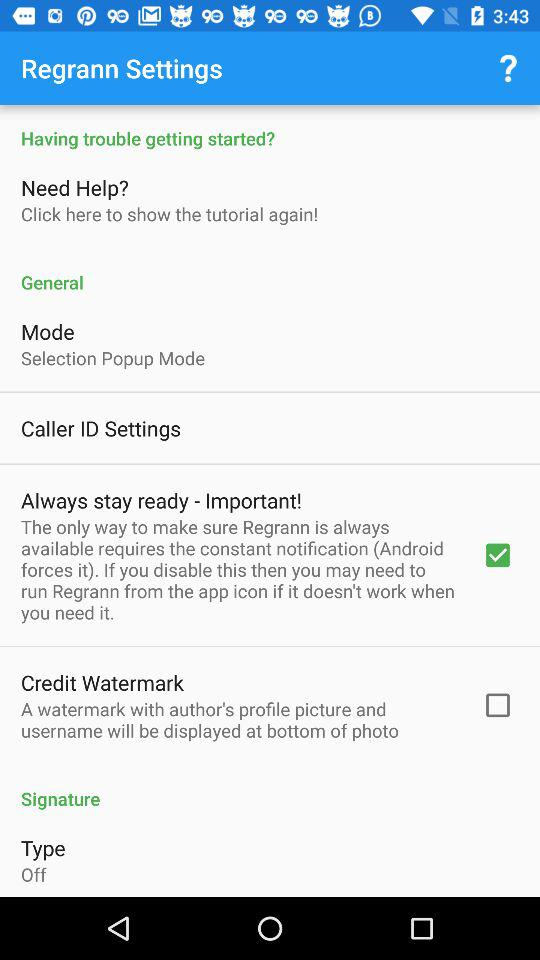Is "Type" off or on? The "Type" is off. 